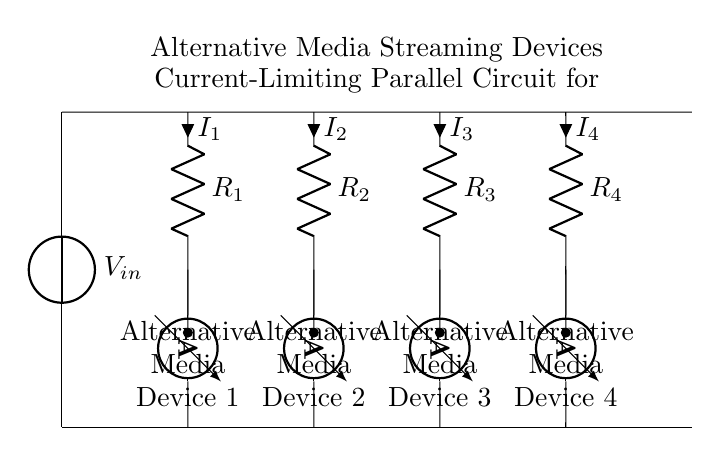What is the input voltage of this circuit? The input voltage is denoted as V_in, which represents the voltage supplied to the circuit from an external source.
Answer: V_in How many resistors are present in the circuit? There are four resistors labeled R_1, R_2, R_3, and R_4 in the circuit, each corresponding to one of the alternative media devices.
Answer: Four What is the function of the ammeters in the circuit? The ammeters measure the current flowing through each parallel path, allowing for monitoring of the current drawn by each media device.
Answer: Measure current What happens to the current if one media device fails? If one media device fails, the current supplied to that specific branch would drop to zero, but the other devices would continue to operate as their current paths remain intact.
Answer: Other devices continue operating What is the total voltage across the media devices? The total voltage across the media devices remains equal to the input voltage V_in, since they are connected in parallel, and thus share the same voltage.
Answer: V_in Which component limits the current to each device? The resistors R_1, R_2, R_3, and R_4 serve to limit the current flowing to their respective media devices by providing resistance in the circuit.
Answer: Resistors What type of circuit is illustrated by this diagram? The circuit illustrated is a parallel circuit, as all components are connected across the same two nodes, allowing multiple paths for current flow.
Answer: Parallel circuit 